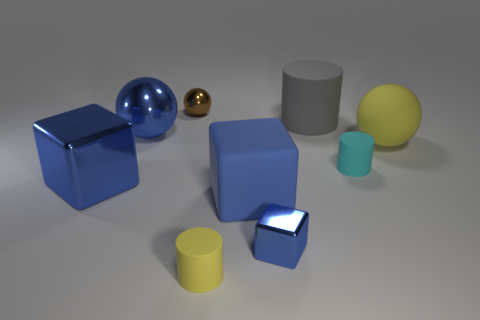The yellow object that is the same shape as the cyan object is what size?
Provide a short and direct response. Small. What material is the large object that is the same shape as the tiny yellow matte thing?
Offer a terse response. Rubber. There is a rubber block that is the same color as the large metal sphere; what size is it?
Your answer should be compact. Large. There is a blue object that is both in front of the tiny cyan rubber cylinder and on the left side of the yellow rubber cylinder; what size is it?
Provide a succinct answer. Large. There is a ball to the left of the small brown sphere; what size is it?
Your answer should be very brief. Large. The tiny shiny thing that is the same color as the rubber block is what shape?
Your answer should be compact. Cube. What is the shape of the yellow object in front of the metal cube that is on the left side of the yellow thing that is left of the gray rubber cylinder?
Provide a short and direct response. Cylinder. What number of rubber things are big yellow balls or big things?
Offer a terse response. 3. What material is the big sphere left of the shiny thing on the right side of the small yellow thing?
Keep it short and to the point. Metal. Is the number of small matte objects that are in front of the large blue metallic cube greater than the number of tiny yellow matte cylinders?
Your answer should be very brief. No. 